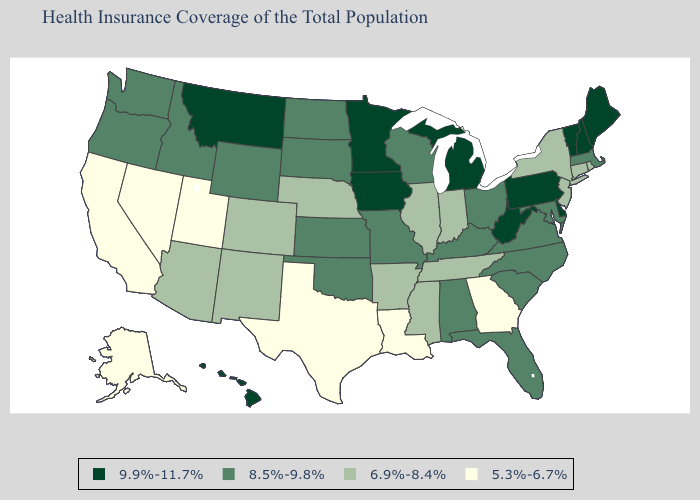Does Minnesota have the same value as New Hampshire?
Write a very short answer. Yes. Does Oregon have the highest value in the USA?
Give a very brief answer. No. Does the first symbol in the legend represent the smallest category?
Short answer required. No. What is the highest value in the MidWest ?
Answer briefly. 9.9%-11.7%. Does Georgia have the lowest value in the South?
Give a very brief answer. Yes. What is the value of Colorado?
Answer briefly. 6.9%-8.4%. What is the lowest value in the USA?
Keep it brief. 5.3%-6.7%. What is the value of Tennessee?
Write a very short answer. 6.9%-8.4%. What is the value of Wyoming?
Quick response, please. 8.5%-9.8%. Does Indiana have the lowest value in the MidWest?
Keep it brief. Yes. What is the value of Iowa?
Be succinct. 9.9%-11.7%. Does Alabama have a higher value than California?
Be succinct. Yes. Does New Hampshire have the lowest value in the USA?
Quick response, please. No. What is the value of Montana?
Quick response, please. 9.9%-11.7%. Does the first symbol in the legend represent the smallest category?
Give a very brief answer. No. 